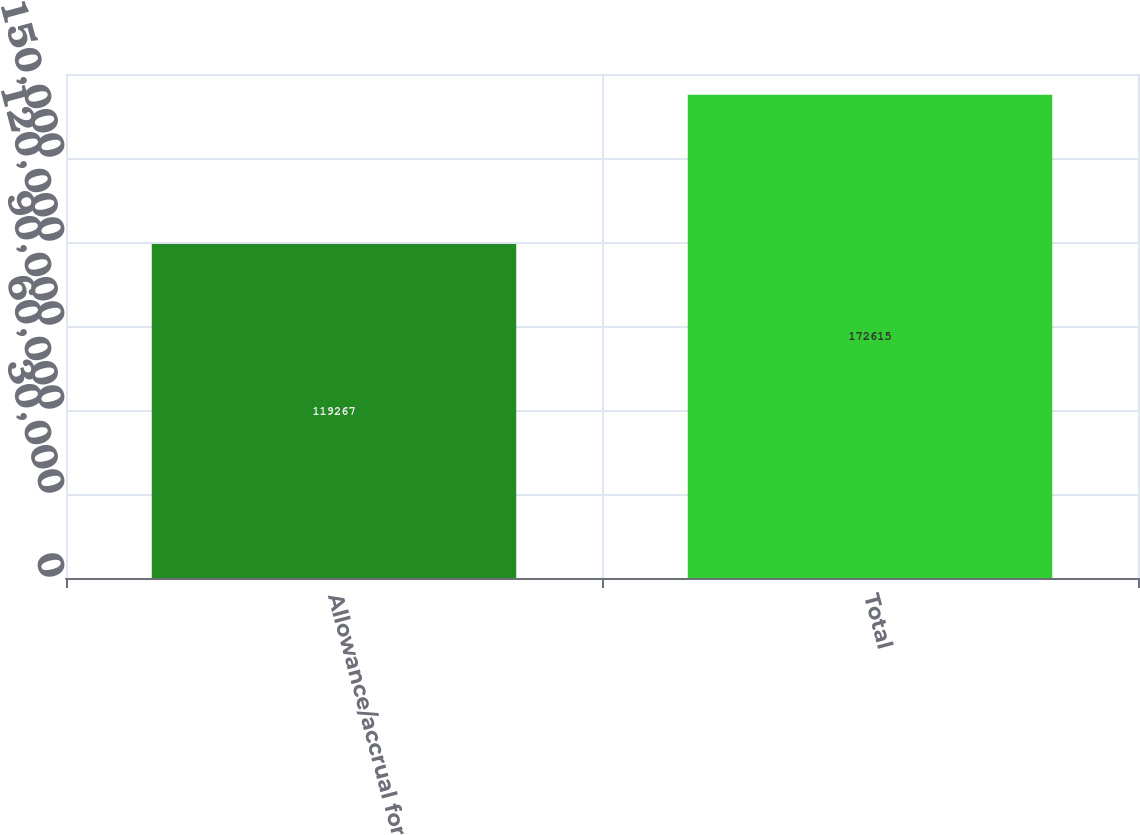Convert chart. <chart><loc_0><loc_0><loc_500><loc_500><bar_chart><fcel>Allowance/accrual for<fcel>Total<nl><fcel>119267<fcel>172615<nl></chart> 